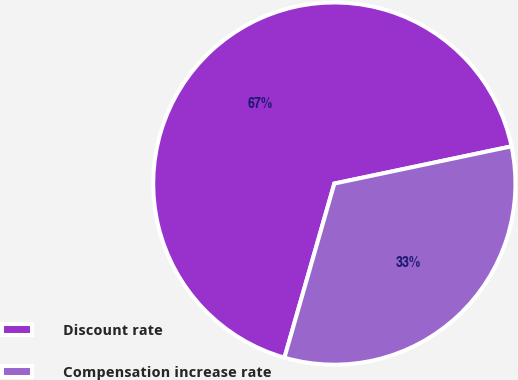Convert chart. <chart><loc_0><loc_0><loc_500><loc_500><pie_chart><fcel>Discount rate<fcel>Compensation increase rate<nl><fcel>67.26%<fcel>32.74%<nl></chart> 